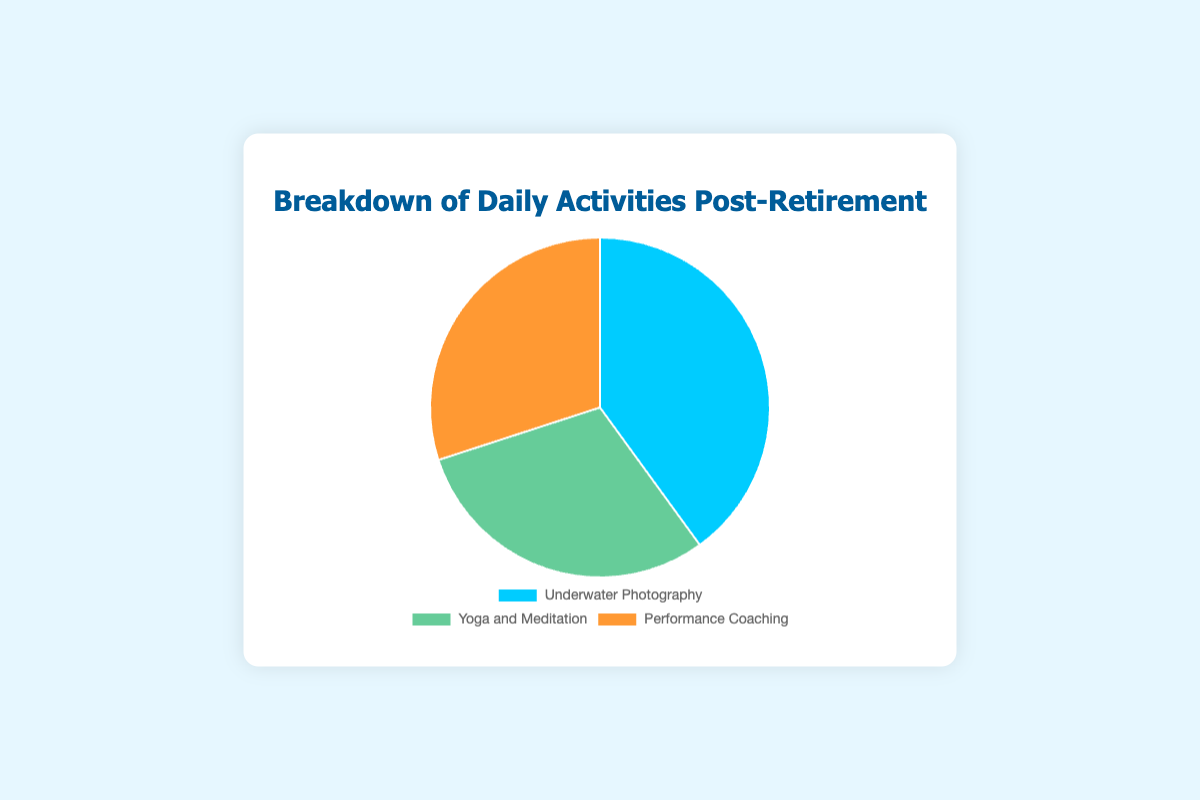What percentage of the activities involve coaching others? Look at the segment labeled 'Performance Coaching' in the pie chart and note its percentage value.
Answer: 30% Which activity occupies the largest portion of the pie chart? Compare the labeled segments of the pie chart and identify the one with the highest percentage.
Answer: Underwater Photography How much more time is spent on Underwater Photography compared to Yoga and Meditation? Subtract the percentage of Yoga and Meditation from the percentage of Underwater Photography: \(40\% - 30\% = 10\%\).
Answer: 10% Are Yoga and Meditation and Performance Coaching equally important in the breakdown of daily activities? Check if the percentage values for Yoga and Meditation and Performance Coaching are equal. Both segments are labeled with 30%.
Answer: Yes What is the combined percentage of Yoga and Meditation and Performance Coaching? Add the percentage values of Yoga and Meditation (30%) and Performance Coaching (30%): \(30\% + 30\% = 60\%\).
Answer: 60% What is the total percentage of the activities that involve physical or mental conditioning? Sum the percentages of Underwater Photography (physical activity) and Yoga and Meditation (mental conditioning): \(40\% + 30\% = 70\%\).
Answer: 70% Which segment is represented by the color orange? Identify the color-coding in the legend or segments of the pie chart. The orange segment corresponds to Performance Coaching.
Answer: Performance Coaching 